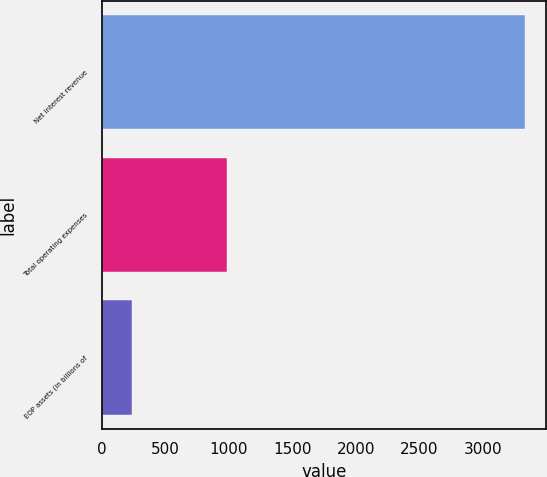Convert chart. <chart><loc_0><loc_0><loc_500><loc_500><bar_chart><fcel>Net interest revenue<fcel>Total operating expenses<fcel>EOP assets (in billions of<nl><fcel>3332<fcel>988<fcel>241<nl></chart> 